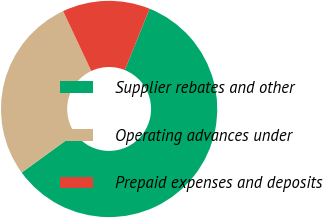Convert chart to OTSL. <chart><loc_0><loc_0><loc_500><loc_500><pie_chart><fcel>Supplier rebates and other<fcel>Operating advances under<fcel>Prepaid expenses and deposits<nl><fcel>58.88%<fcel>28.02%<fcel>13.1%<nl></chart> 